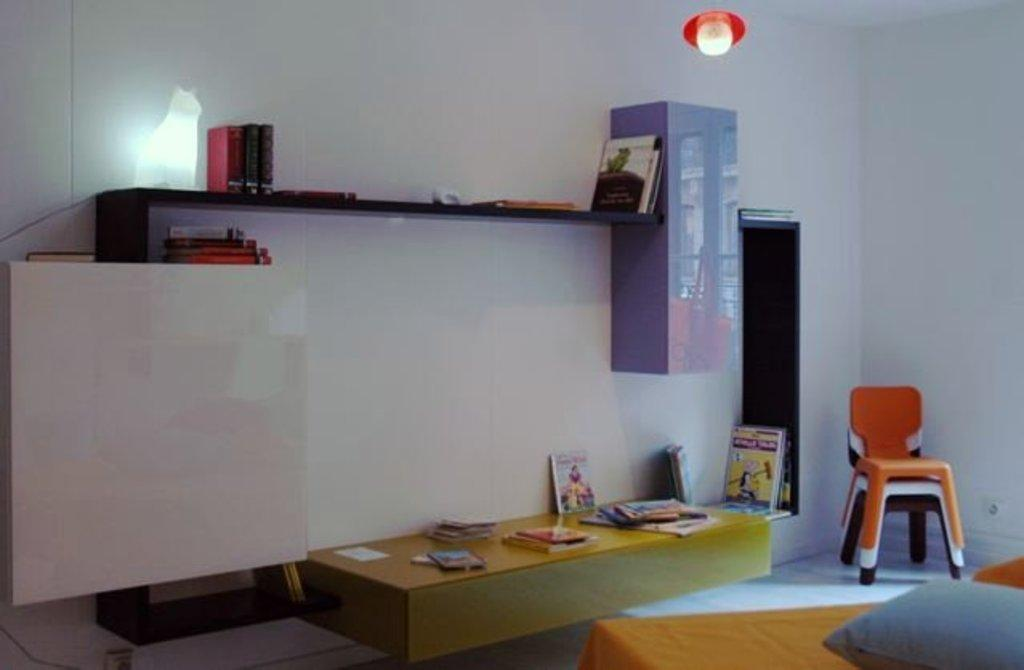What type of furniture is present in the image? There are chairs in the image. What can be used for support or comfort in the image? There is a pillow in the image. What material is visible in the image? There is cloth in the image. What items are present for reading or learning? There are books in the image. What is used for storage or display in the image? There is a rack in the image. What surface is used for placing or working on objects in the image? There is a table in the image. Are there any unspecified objects in the image? Yes, there are unspecified objects in the image. What can be seen in the background of the image? There is a wall and a light in the background of the image. What type of religion is being practiced in the image? There is no indication of any religious practice in the image. What can be used for drawing or coloring in the image? There is no crayon present in the image. 